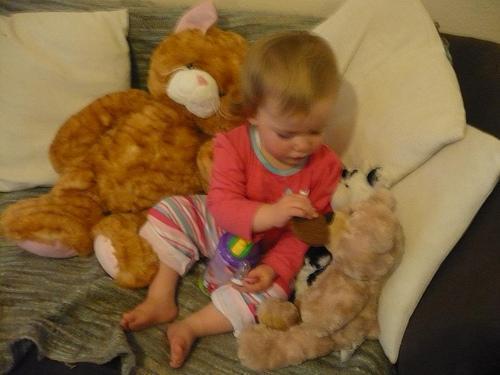How many toys are next to the baby?
Give a very brief answer. 3. How many bears are there?
Give a very brief answer. 2. How many pillows are on the bed?
Give a very brief answer. 3. How many teddy bears can be seen?
Give a very brief answer. 2. 